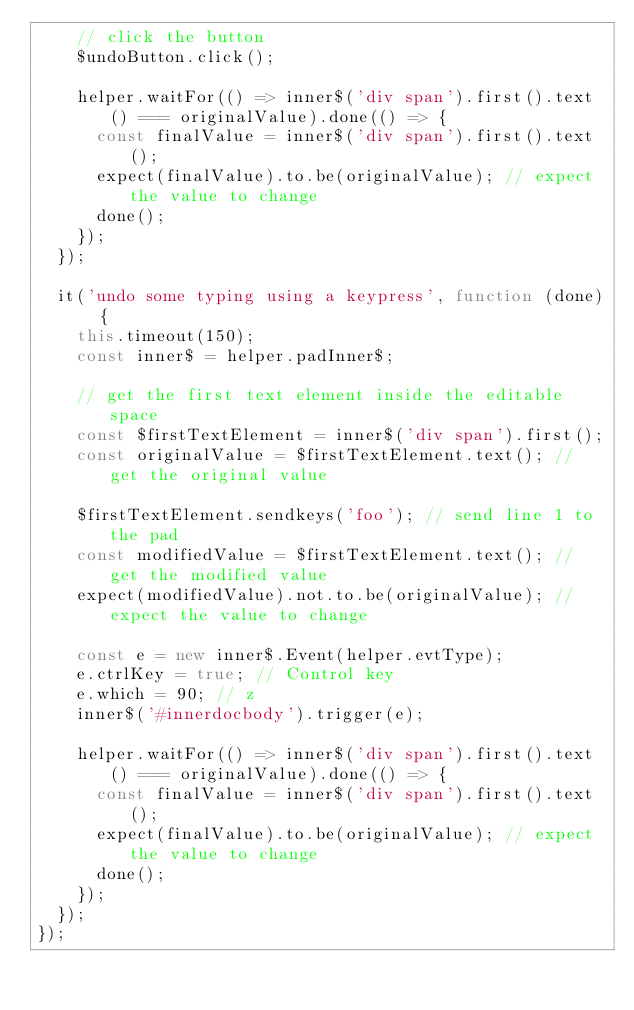<code> <loc_0><loc_0><loc_500><loc_500><_JavaScript_>    // click the button
    $undoButton.click();

    helper.waitFor(() => inner$('div span').first().text() === originalValue).done(() => {
      const finalValue = inner$('div span').first().text();
      expect(finalValue).to.be(originalValue); // expect the value to change
      done();
    });
  });

  it('undo some typing using a keypress', function (done) {
    this.timeout(150);
    const inner$ = helper.padInner$;

    // get the first text element inside the editable space
    const $firstTextElement = inner$('div span').first();
    const originalValue = $firstTextElement.text(); // get the original value

    $firstTextElement.sendkeys('foo'); // send line 1 to the pad
    const modifiedValue = $firstTextElement.text(); // get the modified value
    expect(modifiedValue).not.to.be(originalValue); // expect the value to change

    const e = new inner$.Event(helper.evtType);
    e.ctrlKey = true; // Control key
    e.which = 90; // z
    inner$('#innerdocbody').trigger(e);

    helper.waitFor(() => inner$('div span').first().text() === originalValue).done(() => {
      const finalValue = inner$('div span').first().text();
      expect(finalValue).to.be(originalValue); // expect the value to change
      done();
    });
  });
});
</code> 